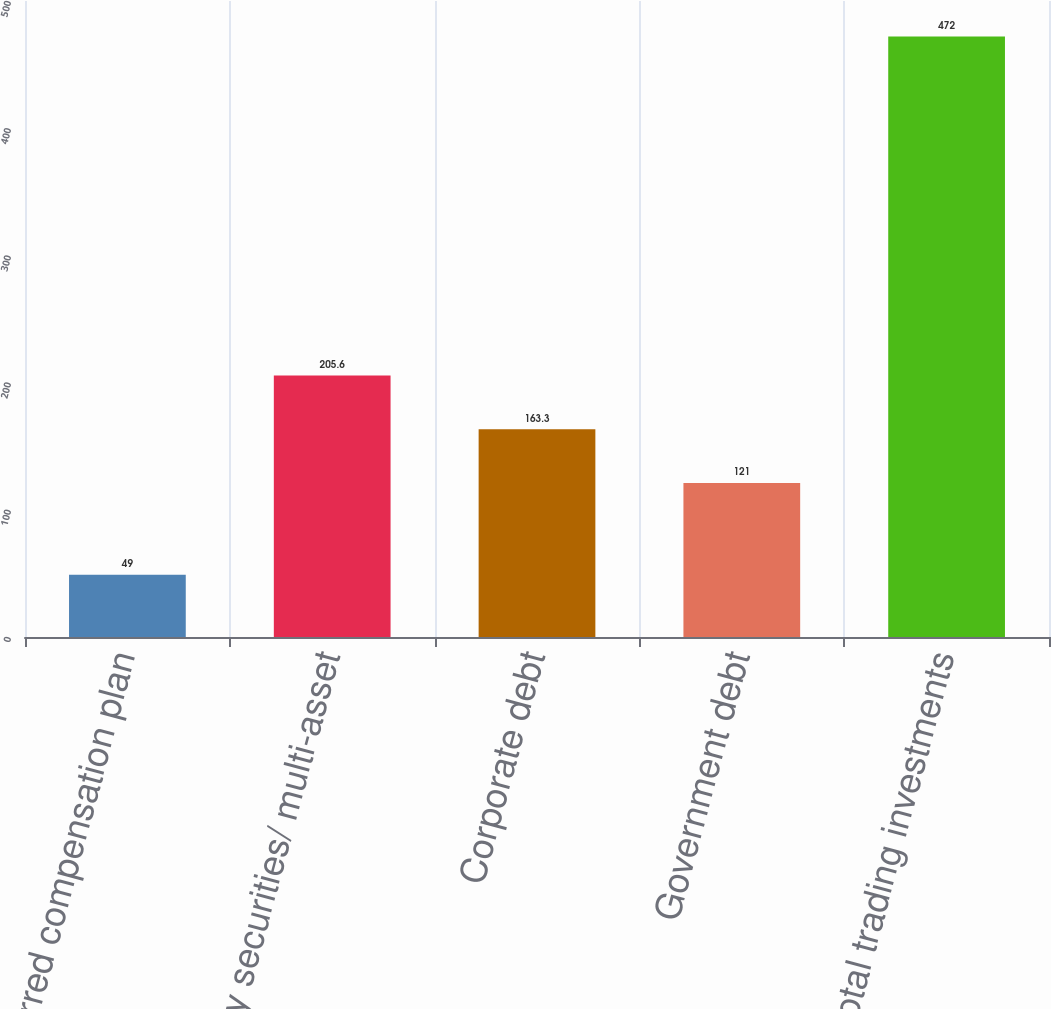Convert chart to OTSL. <chart><loc_0><loc_0><loc_500><loc_500><bar_chart><fcel>Deferred compensation plan<fcel>Equity securities/ multi-asset<fcel>Corporate debt<fcel>Government debt<fcel>Total trading investments<nl><fcel>49<fcel>205.6<fcel>163.3<fcel>121<fcel>472<nl></chart> 